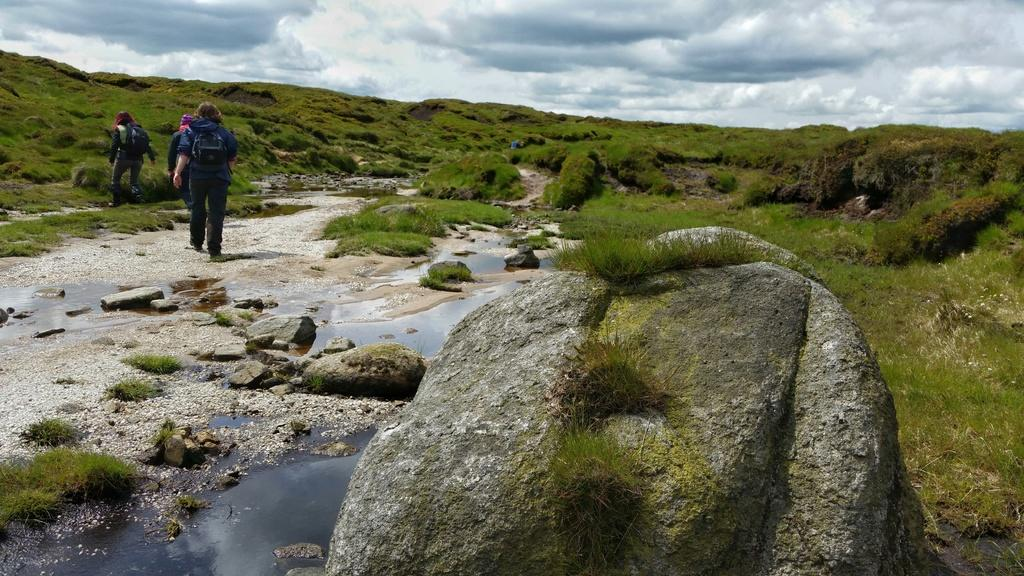How many people are in the image? There are three persons in the image. What are the persons doing in the image? The persons are walking. What type of natural environment is visible in the image? There is water, rocks, and grass visible in the image. What type of salt can be seen on the rocks in the image? There is no salt visible on the rocks in the image. What type of acoustics can be heard from the persons in the image? There is no information about the acoustics or any sounds in the image. 